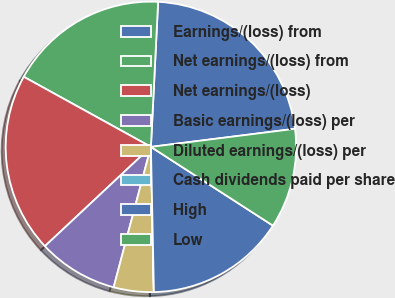Convert chart. <chart><loc_0><loc_0><loc_500><loc_500><pie_chart><fcel>Earnings/(loss) from<fcel>Net earnings/(loss) from<fcel>Net earnings/(loss)<fcel>Basic earnings/(loss) per<fcel>Diluted earnings/(loss) per<fcel>Cash dividends paid per share<fcel>High<fcel>Low<nl><fcel>22.22%<fcel>17.77%<fcel>20.0%<fcel>8.89%<fcel>4.45%<fcel>0.01%<fcel>15.55%<fcel>11.11%<nl></chart> 